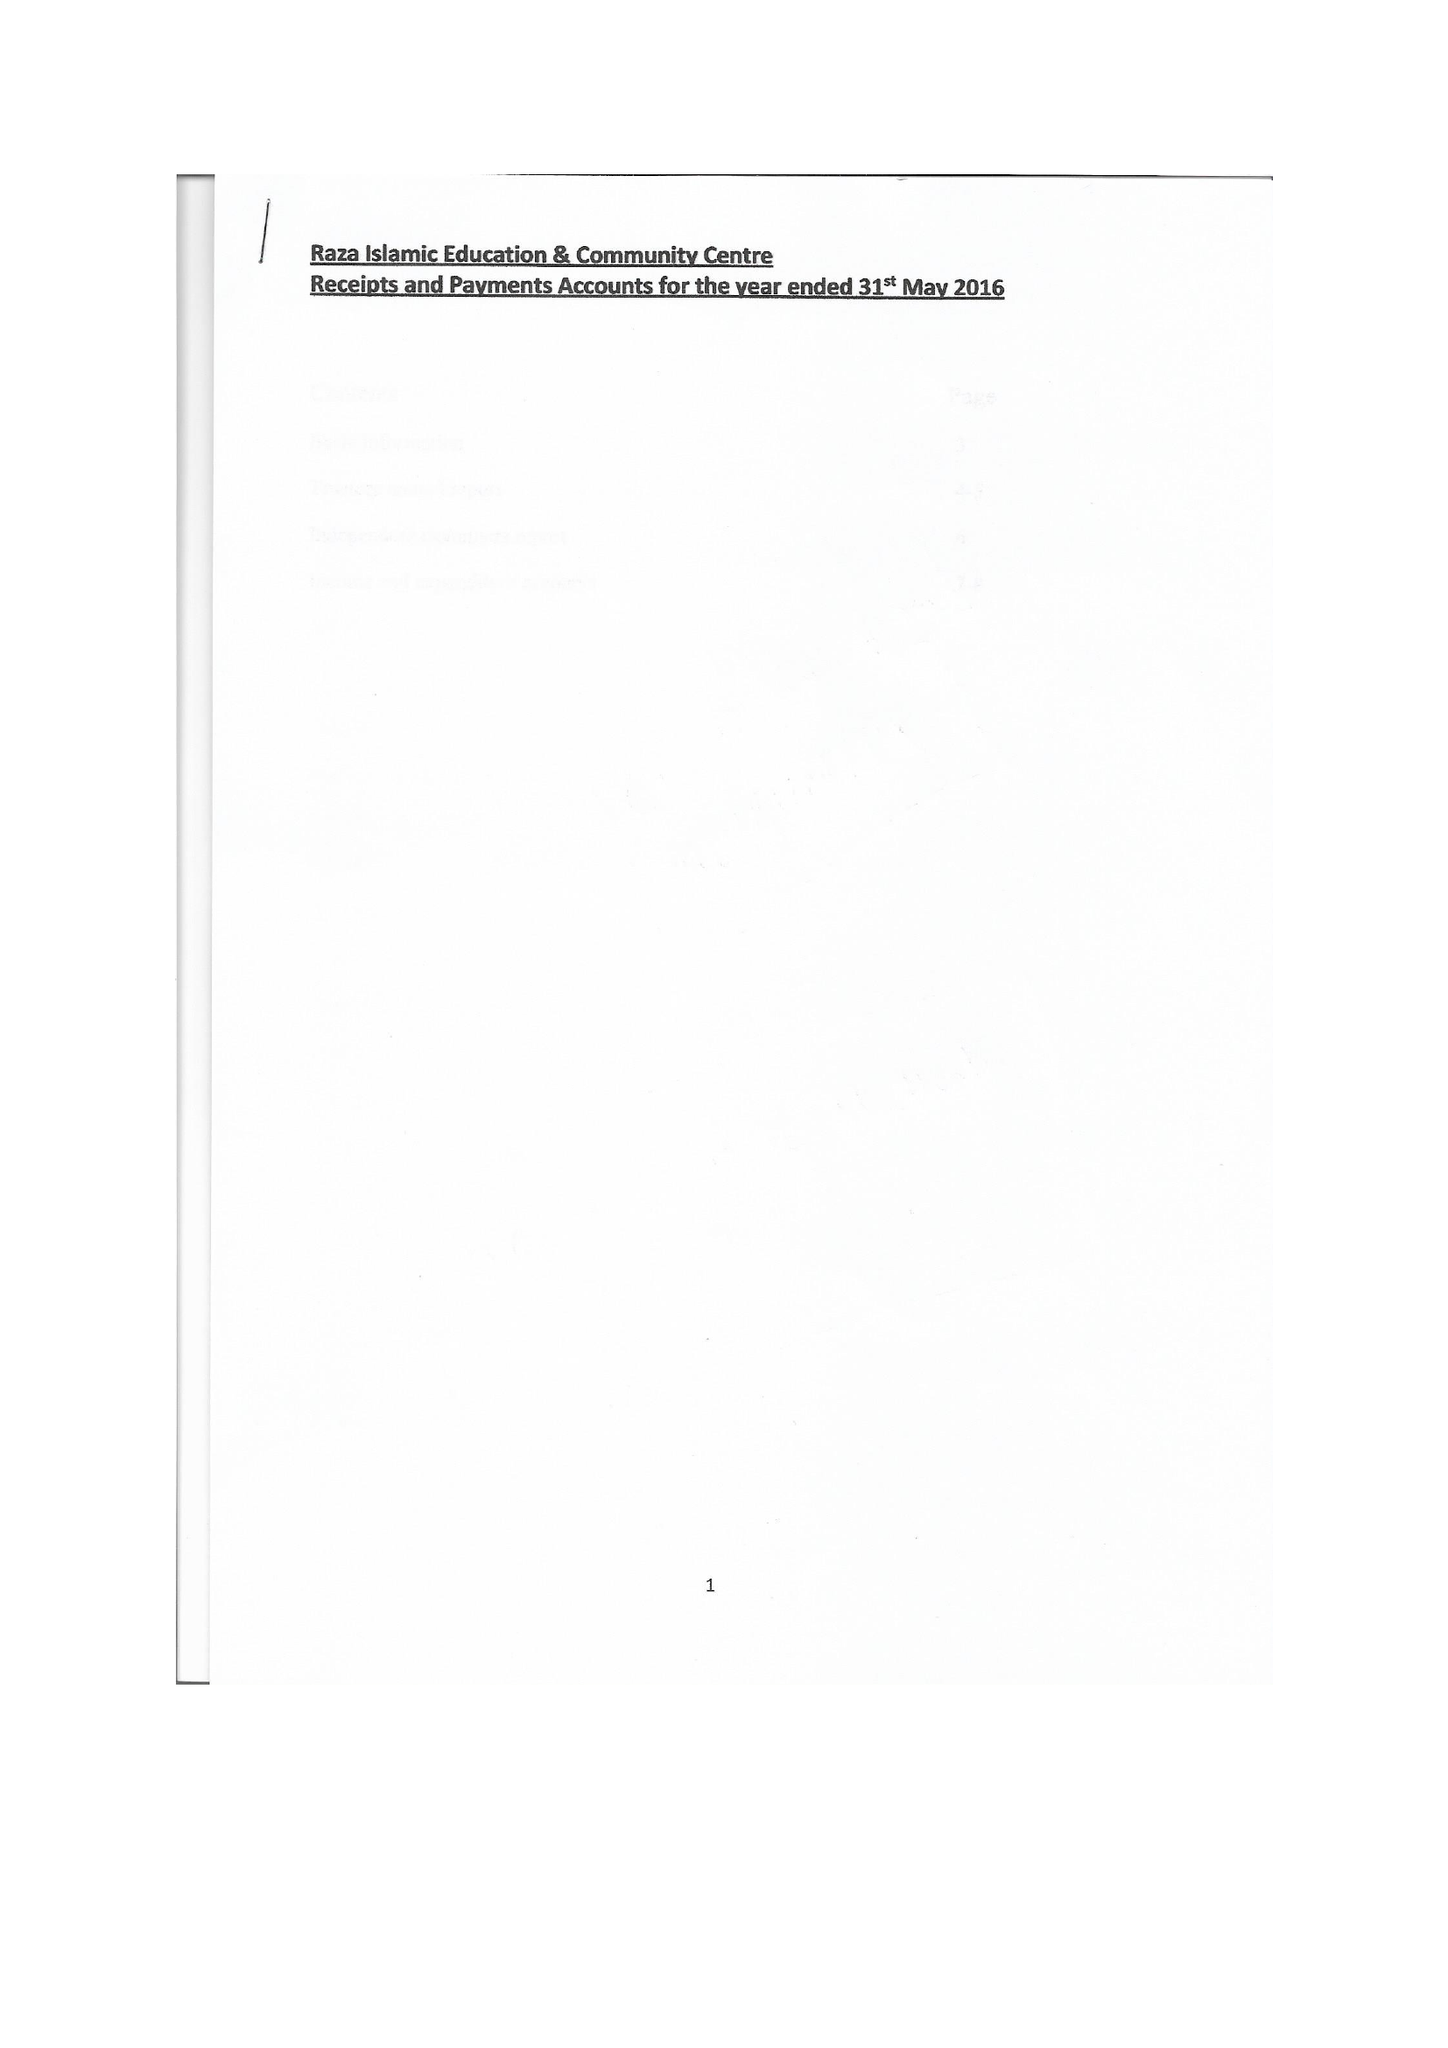What is the value for the charity_number?
Answer the question using a single word or phrase. 1147125 